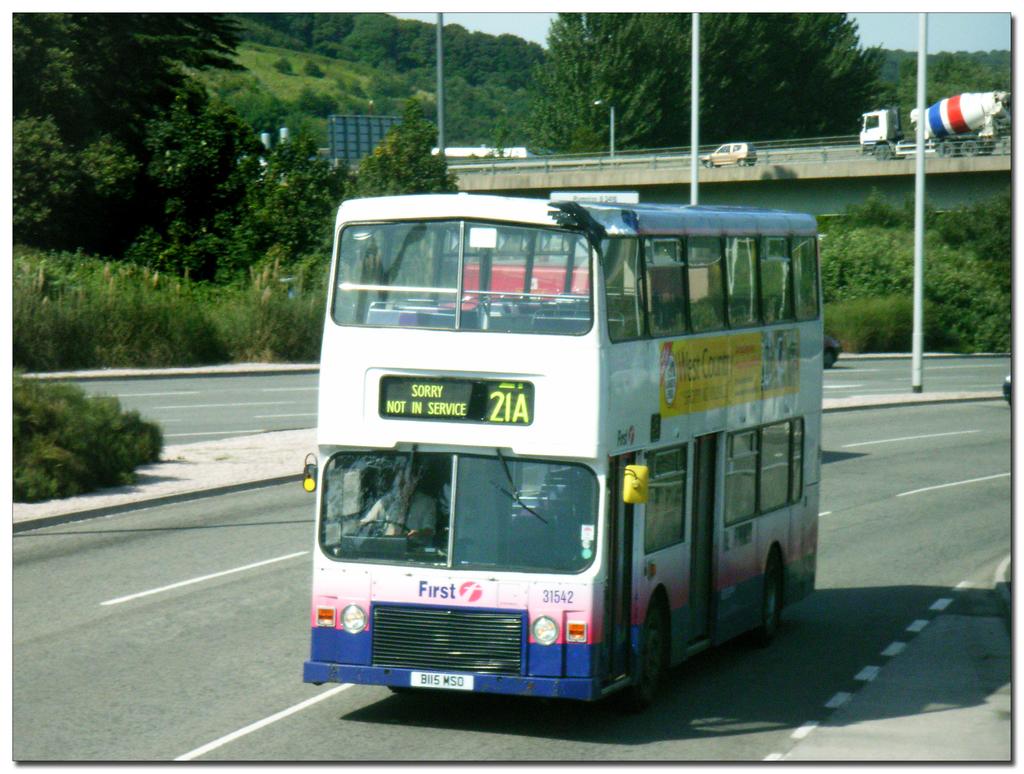What is the word on the front of this bus/?
Give a very brief answer. First. 